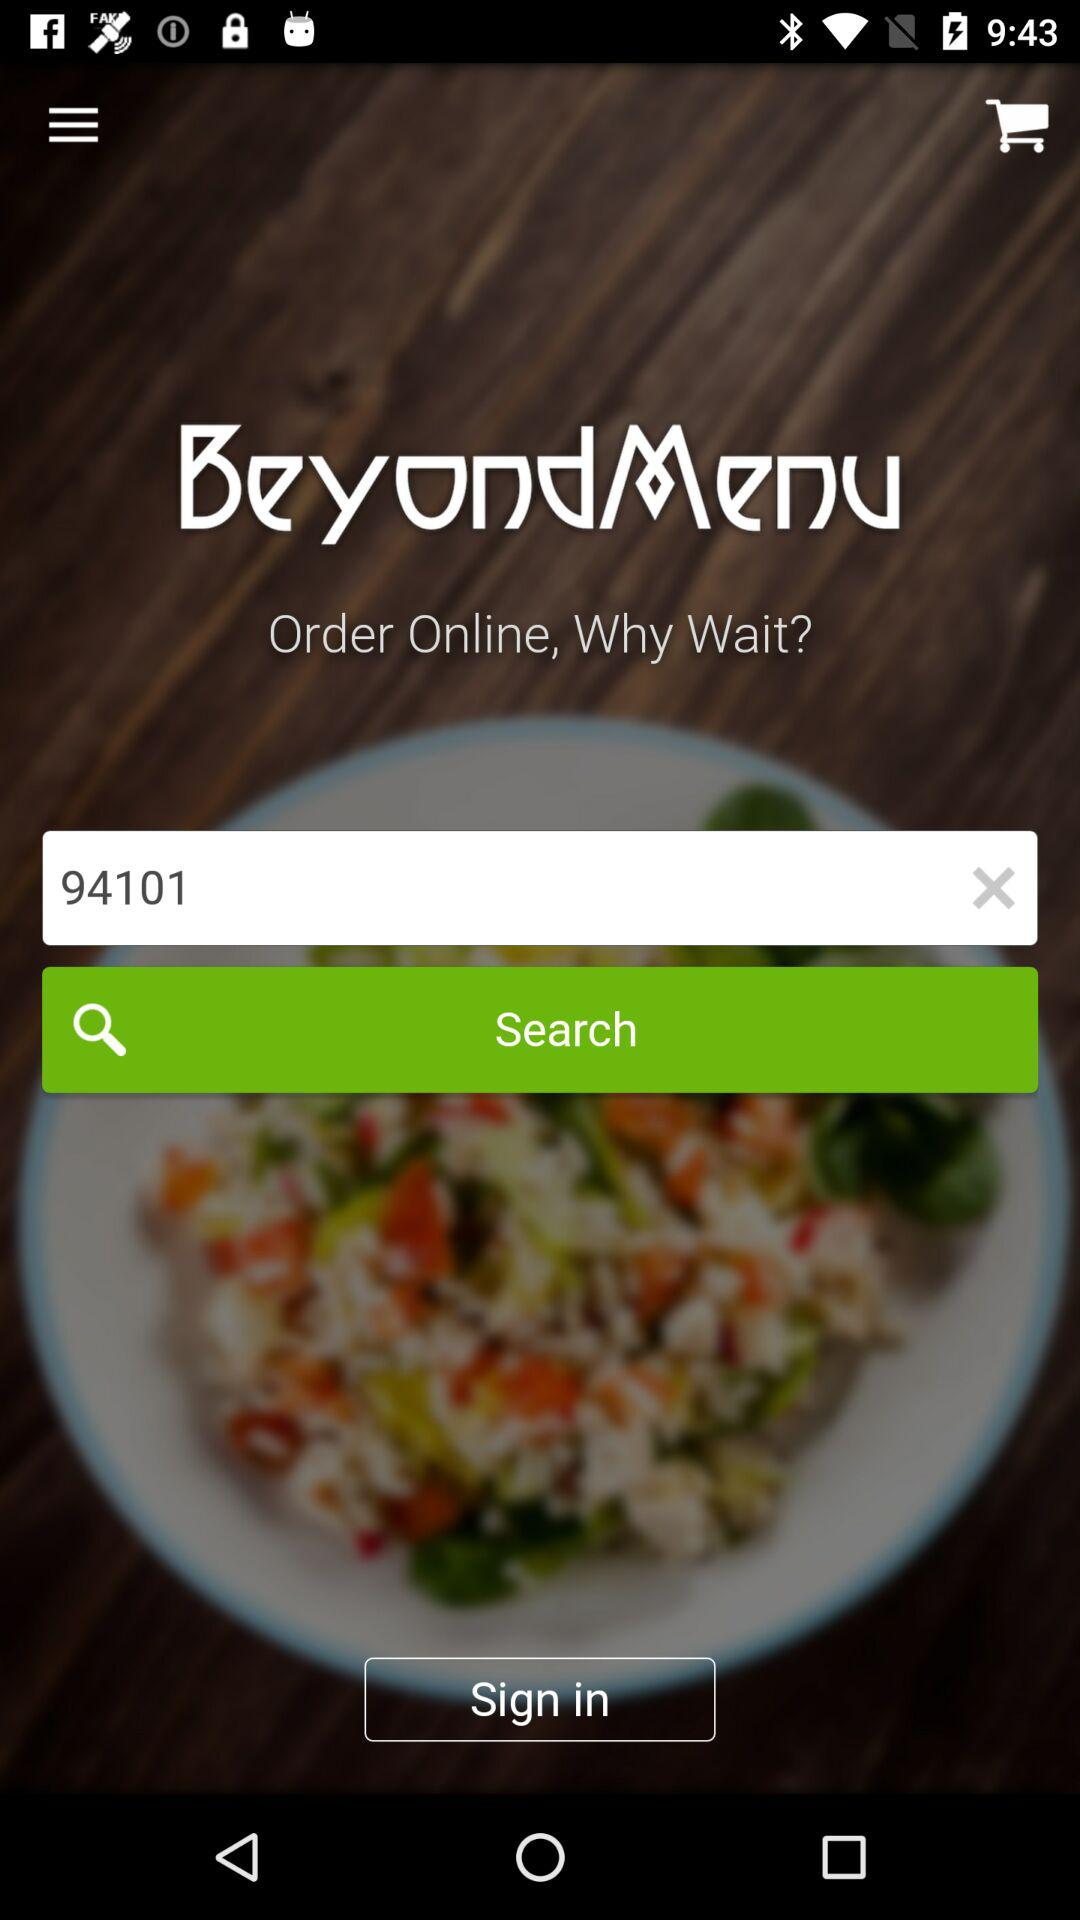What is the app name? The app name is "BeyondMenu". 